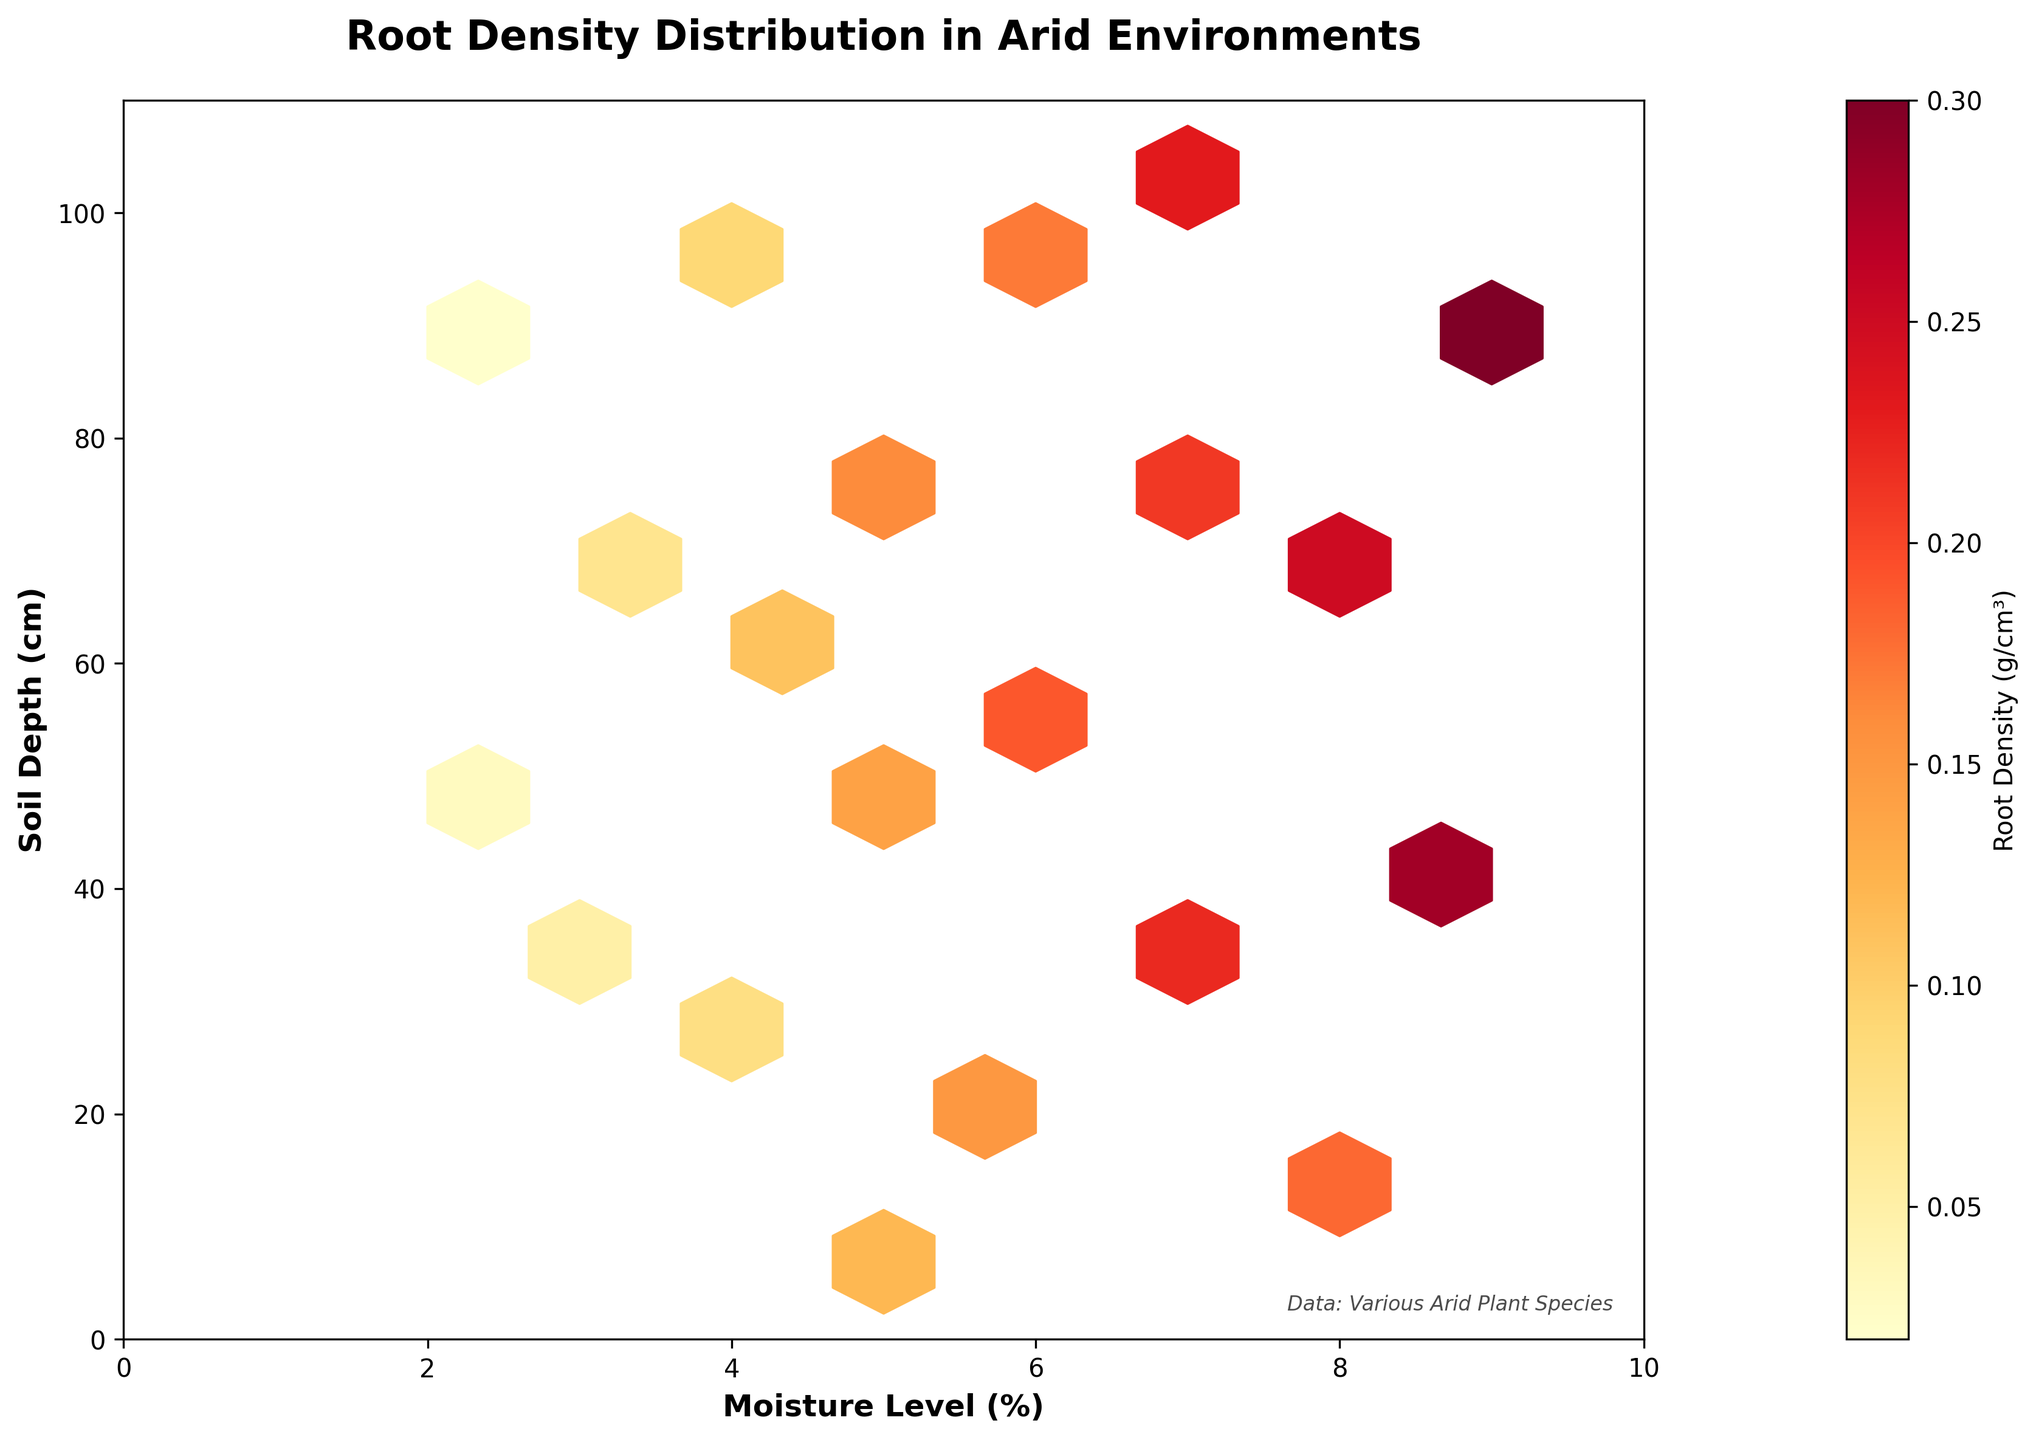What is the title of the plot? The title of the plot is shown at the top and reads "Root Density Distribution in Arid Environments".
Answer: Root Density Distribution in Arid Environments What are the units of measurement for the soil depth axis? The y-axis label specifies the units of measurement for soil depth as centimeters (cm).
Answer: Centimeters (cm) How is the moisture level displayed in the plot? The moisture level is displayed on the x-axis and is measured as a percentage (%).
Answer: Percentage (%) Which color indicates the highest root density in the hexbin plot? The color bar on the right side of the plot shows a gradient from light to dark colors, with dark red indicating the highest root density.
Answer: Dark red Compare the root densities at 60 cm soil depth and 20 cm soil depth. Which one is higher? By examining the plot, the root density at 20 cm soil depth falls in a lighter color hexbin, whereas the root density at 60 cm soil depth falls in a darker color hexbin. Darker colors represent higher densities. Therefore, the root density at 60 cm is higher.
Answer: 60 cm is higher What is the average root density at moisture levels 4% and 5%? For moisture levels 4% (root densities at 25, 60, and 100 cm) and 5% (root densities at 10 and 80 cm), the average density can be calculated. Average = (0.08 + 0.11 + 0.09 + 0.12 + 0.16)/5 = 0.112
Answer: 0.112 g/cm³ At what soil depth and moisture level is the highest root density observed? From the darkest hexbin in the plot, the highest root density is located around 85 cm soil depth at 9% moisture level.
Answer: 85 cm and 9% Which plant species has the lowest root density and at what depth and moisture level was it observed? The plant species Opuntia basilaris has the lowest root density of 0.02 g/cm³, observed at 90 cm soil depth and 2% moisture level.
Answer: Opuntia basilaris at 90 cm and 2% How does root density change with increasing soil depth at a constant moisture level of 6%? By examining data points along the 6% moisture level axis, root densities at increasing soil depths (20, 55, 95 cm) are observed. The root densities are 0.15, 0.19, and 0.17 g/cm³, respectively. Root density initially increases and then slightly decreases.
Answer: Increases then slightly decreases 